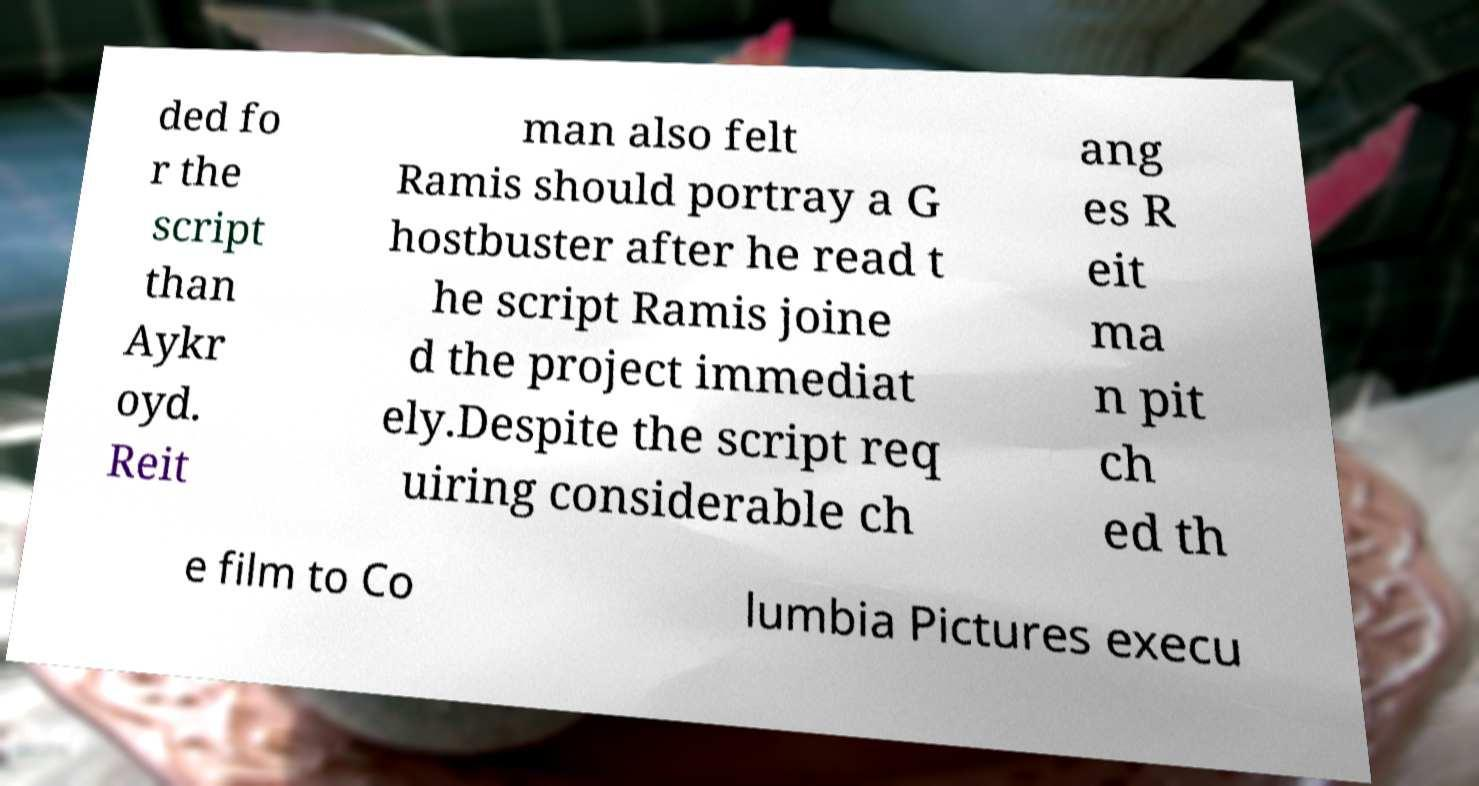Can you read and provide the text displayed in the image?This photo seems to have some interesting text. Can you extract and type it out for me? ded fo r the script than Aykr oyd. Reit man also felt Ramis should portray a G hostbuster after he read t he script Ramis joine d the project immediat ely.Despite the script req uiring considerable ch ang es R eit ma n pit ch ed th e film to Co lumbia Pictures execu 